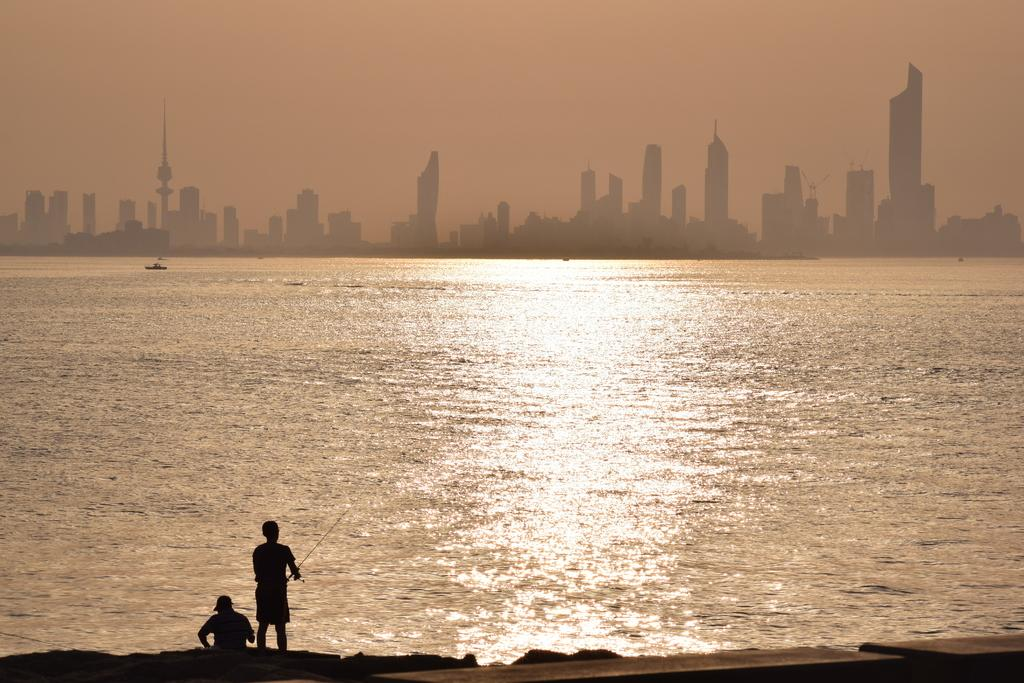What is the man in the image doing? The man is standing in the image and holding a fishing stick. Can you describe the other person in the image? There is another person sitting in the image. What can be seen in the background of the image? There is an ocean visible in the image, as well as buildings in the backdrop. How does the man change the wax on the fishing stick in the image? There is no mention of wax or any need to change it in the image. The man is simply holding a fishing stick. 